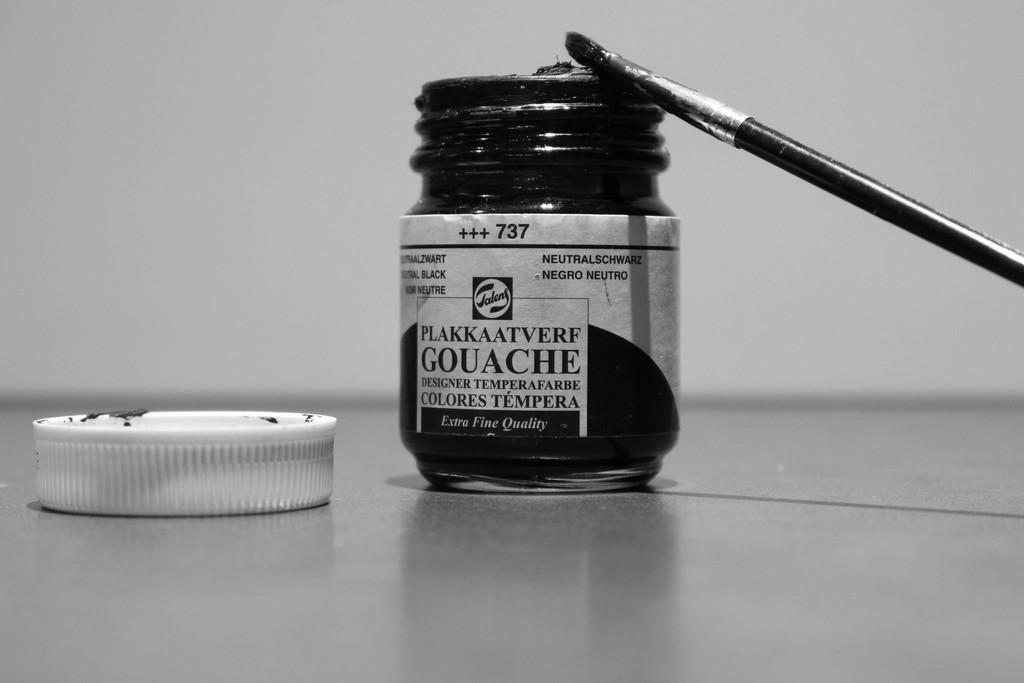<image>
Present a compact description of the photo's key features. Small black bottle that says the numbers 737 on the label. 